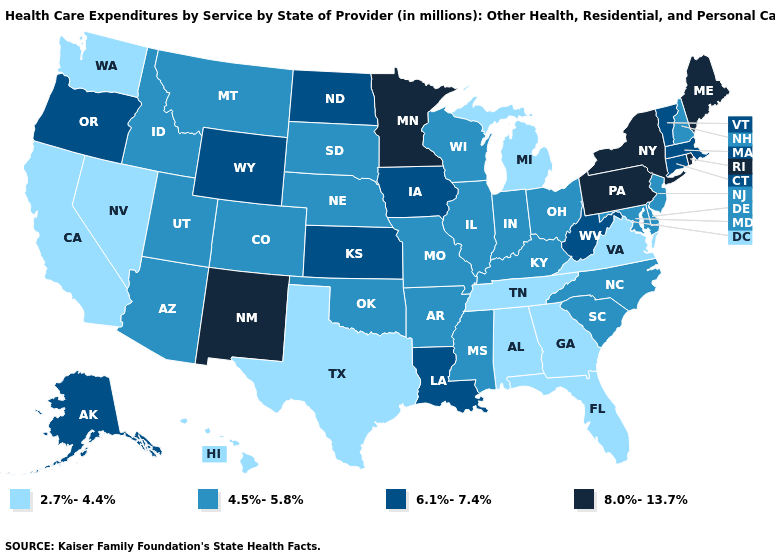Does Tennessee have the lowest value in the USA?
Short answer required. Yes. What is the lowest value in the USA?
Short answer required. 2.7%-4.4%. Is the legend a continuous bar?
Keep it brief. No. Among the states that border Florida , which have the highest value?
Quick response, please. Alabama, Georgia. What is the highest value in states that border Idaho?
Concise answer only. 6.1%-7.4%. What is the lowest value in states that border Vermont?
Concise answer only. 4.5%-5.8%. Is the legend a continuous bar?
Short answer required. No. Name the states that have a value in the range 4.5%-5.8%?
Keep it brief. Arizona, Arkansas, Colorado, Delaware, Idaho, Illinois, Indiana, Kentucky, Maryland, Mississippi, Missouri, Montana, Nebraska, New Hampshire, New Jersey, North Carolina, Ohio, Oklahoma, South Carolina, South Dakota, Utah, Wisconsin. What is the value of Nebraska?
Quick response, please. 4.5%-5.8%. Name the states that have a value in the range 2.7%-4.4%?
Write a very short answer. Alabama, California, Florida, Georgia, Hawaii, Michigan, Nevada, Tennessee, Texas, Virginia, Washington. Name the states that have a value in the range 6.1%-7.4%?
Give a very brief answer. Alaska, Connecticut, Iowa, Kansas, Louisiana, Massachusetts, North Dakota, Oregon, Vermont, West Virginia, Wyoming. Which states have the lowest value in the USA?
Keep it brief. Alabama, California, Florida, Georgia, Hawaii, Michigan, Nevada, Tennessee, Texas, Virginia, Washington. What is the lowest value in the USA?
Write a very short answer. 2.7%-4.4%. Which states have the highest value in the USA?
Short answer required. Maine, Minnesota, New Mexico, New York, Pennsylvania, Rhode Island. Does Connecticut have the highest value in the Northeast?
Give a very brief answer. No. 